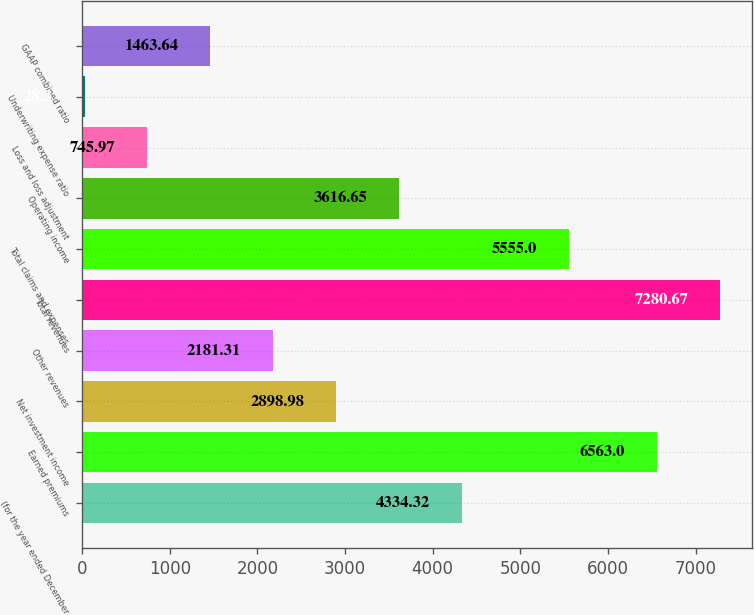Convert chart to OTSL. <chart><loc_0><loc_0><loc_500><loc_500><bar_chart><fcel>(for the year ended December<fcel>Earned premiums<fcel>Net investment income<fcel>Other revenues<fcel>Total revenues<fcel>Total claims and expenses<fcel>Operating income<fcel>Loss and loss adjustment<fcel>Underwriting expense ratio<fcel>GAAP combined ratio<nl><fcel>4334.32<fcel>6563<fcel>2898.98<fcel>2181.31<fcel>7280.67<fcel>5555<fcel>3616.65<fcel>745.97<fcel>28.3<fcel>1463.64<nl></chart> 